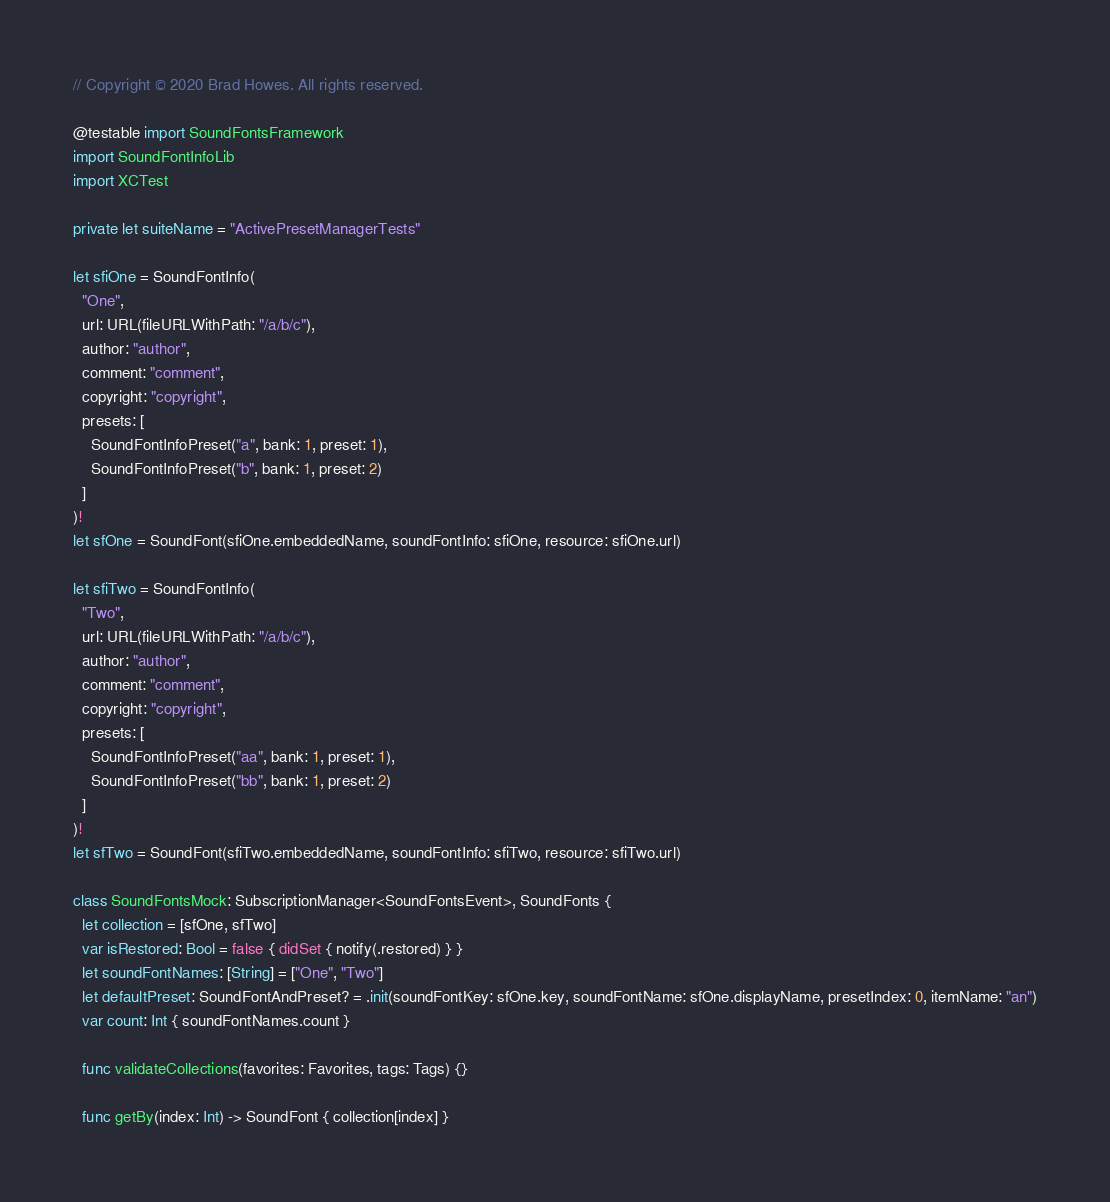<code> <loc_0><loc_0><loc_500><loc_500><_Swift_>// Copyright © 2020 Brad Howes. All rights reserved.

@testable import SoundFontsFramework
import SoundFontInfoLib
import XCTest

private let suiteName = "ActivePresetManagerTests"

let sfiOne = SoundFontInfo(
  "One",
  url: URL(fileURLWithPath: "/a/b/c"),
  author: "author",
  comment: "comment",
  copyright: "copyright",
  presets: [
    SoundFontInfoPreset("a", bank: 1, preset: 1),
    SoundFontInfoPreset("b", bank: 1, preset: 2)
  ]
)!
let sfOne = SoundFont(sfiOne.embeddedName, soundFontInfo: sfiOne, resource: sfiOne.url)

let sfiTwo = SoundFontInfo(
  "Two",
  url: URL(fileURLWithPath: "/a/b/c"),
  author: "author",
  comment: "comment",
  copyright: "copyright",
  presets: [
    SoundFontInfoPreset("aa", bank: 1, preset: 1),
    SoundFontInfoPreset("bb", bank: 1, preset: 2)
  ]
)!
let sfTwo = SoundFont(sfiTwo.embeddedName, soundFontInfo: sfiTwo, resource: sfiTwo.url)

class SoundFontsMock: SubscriptionManager<SoundFontsEvent>, SoundFonts {
  let collection = [sfOne, sfTwo]
  var isRestored: Bool = false { didSet { notify(.restored) } }
  let soundFontNames: [String] = ["One", "Two"]
  let defaultPreset: SoundFontAndPreset? = .init(soundFontKey: sfOne.key, soundFontName: sfOne.displayName, presetIndex: 0, itemName: "an")
  var count: Int { soundFontNames.count }

  func validateCollections(favorites: Favorites, tags: Tags) {}

  func getBy(index: Int) -> SoundFont { collection[index] }
</code> 